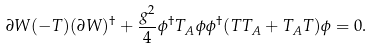Convert formula to latex. <formula><loc_0><loc_0><loc_500><loc_500>\partial W ( - T ) ( \partial W ) ^ { \dagger } + \frac { g ^ { 2 } } { 4 } \phi ^ { \dagger } T _ { A } \phi \phi ^ { \dagger } ( T T _ { A } + T _ { A } T ) \phi = 0 .</formula> 